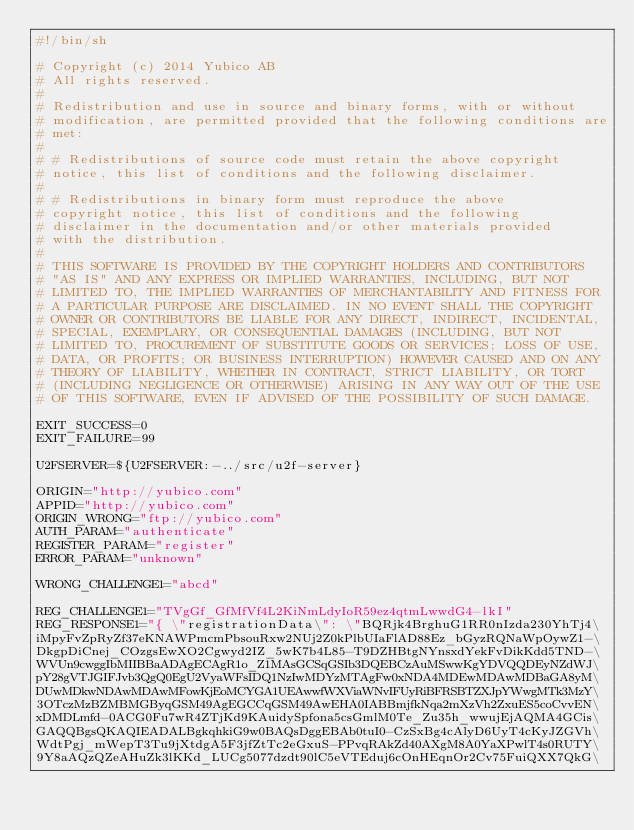<code> <loc_0><loc_0><loc_500><loc_500><_Bash_>#!/bin/sh

# Copyright (c) 2014 Yubico AB
# All rights reserved.
#
# Redistribution and use in source and binary forms, with or without
# modification, are permitted provided that the following conditions are
# met:
#
# # Redistributions of source code must retain the above copyright
# notice, this list of conditions and the following disclaimer.
#
# # Redistributions in binary form must reproduce the above
# copyright notice, this list of conditions and the following
# disclaimer in the documentation and/or other materials provided
# with the distribution.
#
# THIS SOFTWARE IS PROVIDED BY THE COPYRIGHT HOLDERS AND CONTRIBUTORS
# "AS IS" AND ANY EXPRESS OR IMPLIED WARRANTIES, INCLUDING, BUT NOT
# LIMITED TO, THE IMPLIED WARRANTIES OF MERCHANTABILITY AND FITNESS FOR
# A PARTICULAR PURPOSE ARE DISCLAIMED. IN NO EVENT SHALL THE COPYRIGHT
# OWNER OR CONTRIBUTORS BE LIABLE FOR ANY DIRECT, INDIRECT, INCIDENTAL,
# SPECIAL, EXEMPLARY, OR CONSEQUENTIAL DAMAGES (INCLUDING, BUT NOT
# LIMITED TO, PROCUREMENT OF SUBSTITUTE GOODS OR SERVICES; LOSS OF USE,
# DATA, OR PROFITS; OR BUSINESS INTERRUPTION) HOWEVER CAUSED AND ON ANY
# THEORY OF LIABILITY, WHETHER IN CONTRACT, STRICT LIABILITY, OR TORT
# (INCLUDING NEGLIGENCE OR OTHERWISE) ARISING IN ANY WAY OUT OF THE USE
# OF THIS SOFTWARE, EVEN IF ADVISED OF THE POSSIBILITY OF SUCH DAMAGE.

EXIT_SUCCESS=0
EXIT_FAILURE=99

U2FSERVER=${U2FSERVER:-../src/u2f-server}

ORIGIN="http://yubico.com"
APPID="http://yubico.com"
ORIGIN_WRONG="ftp://yubico.com"
AUTH_PARAM="authenticate"
REGISTER_PARAM="register"
ERROR_PARAM="unknown"

WRONG_CHALLENGE1="abcd"

REG_CHALLENGE1="TVgGf_GfMfVf4L2KiNmLdyIoR59ez4qtmLwwdG4-lkI"
REG_RESPONSE1="{ \"registrationData\": \"BQRjk4BrghuG1RR0nIzda230YhTj4\
iMpyFvZpRyZf37eKNAWPmcmPbsouRxw2NUj2Z0kPlbUIaFlAD88Ez_bGyzRQNaWpOywZ1-\
DkgpDiCnej_COzgsEwXO2Cgwyd2IZ_5wK7b4L85-T9DZHBtgNYnsxdYekFvDikKdd5TND-\
WVUn9cwggIbMIIBBaADAgECAgR1o_Z1MAsGCSqGSIb3DQEBCzAuMSwwKgYDVQQDEyNZdWJ\
pY28gVTJGIFJvb3QgQ0EgU2VyaWFsIDQ1NzIwMDYzMTAgFw0xNDA4MDEwMDAwMDBaGA8yM\
DUwMDkwNDAwMDAwMFowKjEoMCYGA1UEAwwfWXViaWNvIFUyRiBFRSBTZXJpYWwgMTk3MzY\
3OTczMzBZMBMGByqGSM49AgEGCCqGSM49AwEHA0IABBmjfkNqa2mXzVh2ZxuES5coCvvEN\
xDMDLmfd-0ACG0Fu7wR4ZTjKd9KAuidySpfona5csGmlM0Te_Zu35h_wwujEjAQMA4GCis\
GAQQBgsQKAQIEADALBgkqhkiG9w0BAQsDggEBAb0tuI0-CzSxBg4cAlyD6UyT4cKyJZGVh\
WdtPgj_mWepT3Tu9jXtdgA5F3jfZtTc2eGxuS-PPvqRAkZd40AXgM8A0YaXPwlT4s0RUTY\
9Y8aAQzQZeAHuZk3lKKd_LUCg5077dzdt90lC5eVTEduj6cOnHEqnOr2Cv75FuiQXX7QkG\</code> 